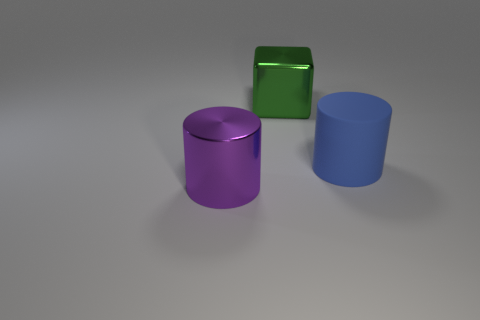What material is the large purple thing?
Your answer should be compact. Metal. What number of other purple objects have the same shape as the rubber object?
Offer a terse response. 1. There is a big metallic object that is to the right of the large purple thing that is left of the green shiny object; what number of green metallic objects are in front of it?
Ensure brevity in your answer.  0. How many metal objects are both behind the large blue rubber cylinder and to the left of the large green metal object?
Make the answer very short. 0. Are there any other things that are made of the same material as the big blue thing?
Offer a terse response. No. Do the big purple cylinder and the big green thing have the same material?
Keep it short and to the point. Yes. What shape is the big metal object behind the metal object that is in front of the large metal object to the right of the purple metallic thing?
Make the answer very short. Cube. Is the number of large green cubes behind the green object less than the number of purple cylinders that are on the right side of the blue thing?
Provide a succinct answer. No. There is a thing that is in front of the cylinder that is right of the green block; what is its shape?
Ensure brevity in your answer.  Cylinder. Is there anything else that has the same color as the large matte cylinder?
Offer a very short reply. No. 